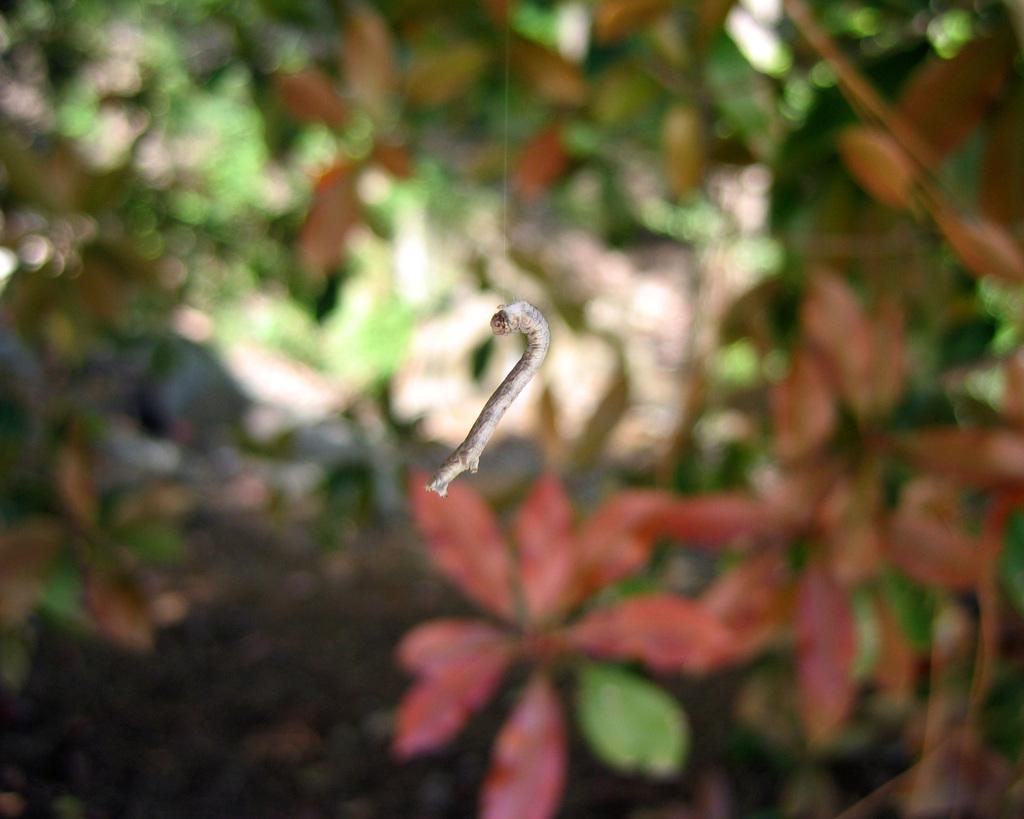Can you describe this image briefly? This image consists of a small stick. There are plants backside. 